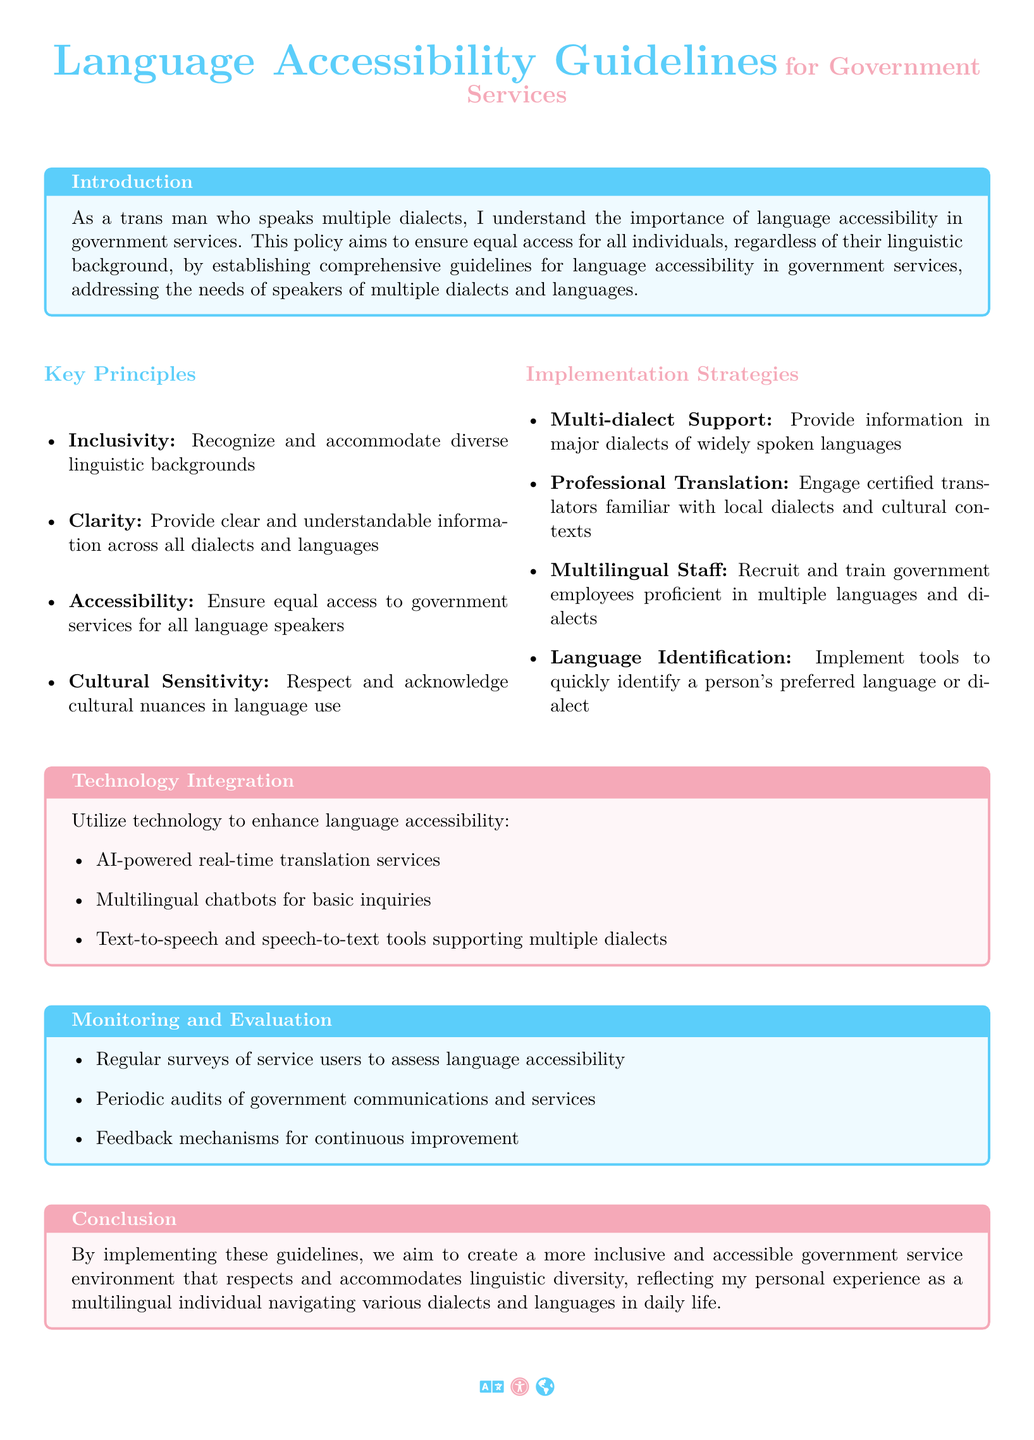What is the title of the document? The title clearly appears at the beginning of the document and is "Language Accessibility Guidelines for Government Services."
Answer: Language Accessibility Guidelines for Government Services What color is used for the key principles section? The document specifies the color used for the key principles section, which is transblue.
Answer: transblue How many key principles are listed in the document? The key principles are outlined in a bulleted list within the document, and there are four principles mentioned.
Answer: four Which integration method is mentioned for enhancing language accessibility? The technology integration section lists several methods, one of which is "AI-powered real-time translation services."
Answer: AI-powered real-time translation services What is one of the strategies for implementation? The document provides a list of implementation strategies, one of which is "Multi-dialect Support."
Answer: Multi-dialect Support What is the purpose of regular surveys mentioned under monitoring? The document suggests that regular surveys help to assess the level of language accessibility in government services.
Answer: assess language accessibility What specific cultural aspect does the policy emphasize? The policy emphasizes the importance of "Cultural Sensitivity" in communication and service provision.
Answer: Cultural Sensitivity What type of feedback mechanisms are included for improvement? The document states that feedback mechanisms are put in place for "continuous improvement" of language services.
Answer: continuous improvement 